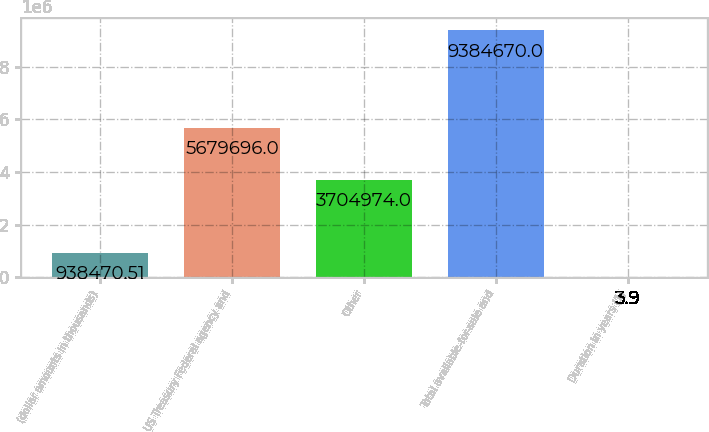<chart> <loc_0><loc_0><loc_500><loc_500><bar_chart><fcel>(dollar amounts in thousands)<fcel>US Treasury Federal agency and<fcel>Other<fcel>Total available-for-sale and<fcel>Duration in years (1)<nl><fcel>938471<fcel>5.6797e+06<fcel>3.70497e+06<fcel>9.38467e+06<fcel>3.9<nl></chart> 